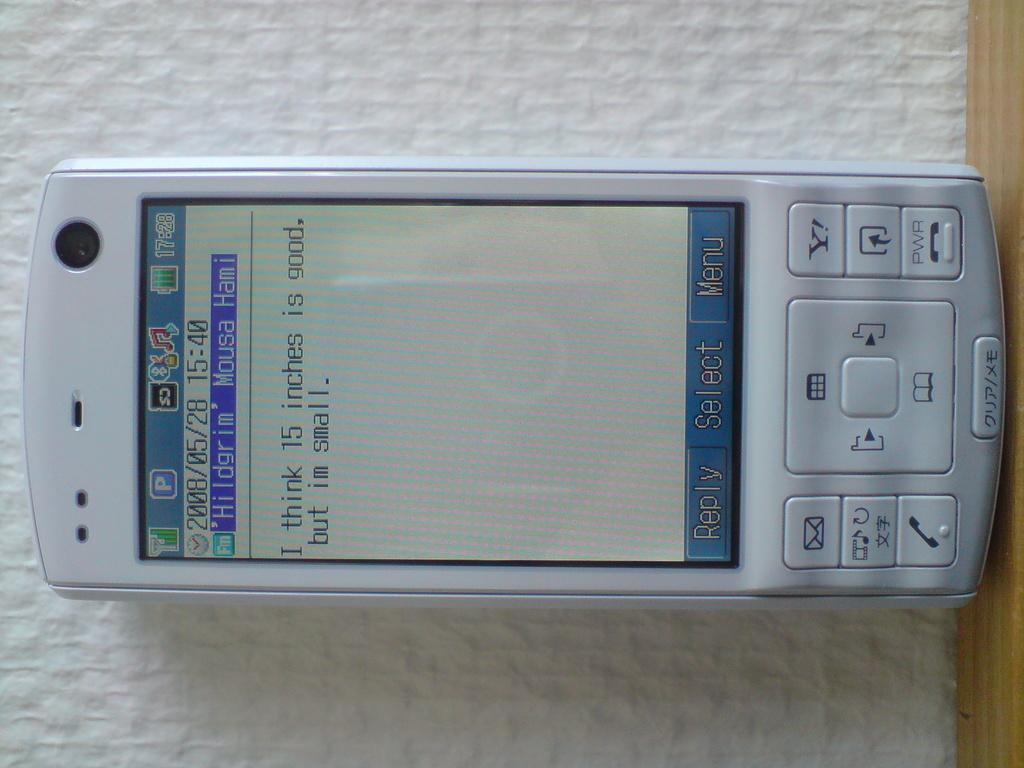<image>
Share a concise interpretation of the image provided. An old smartphone with bottons in Japanese shows texting message about 15 inches being good. 